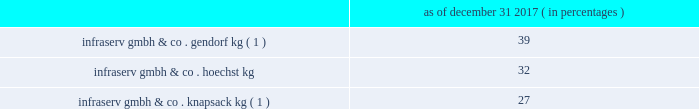Table of contents other equity method investments infraservs .
We hold indirect ownership interests in several german infraserv groups that own and develop industrial parks and provide on-site general and administrative support to tenants .
Our ownership interest in the equity investments in infraserv affiliates are as follows : as of december 31 , 2017 ( in percentages ) infraserv gmbh & co .
Gendorf kg ( 1 ) ................................................................................................... .
39 .
Infraserv gmbh & co .
Knapsack kg ( 1 ) ................................................................................................ .
27 ______________________________ ( 1 ) see note 29 - subsequent events in the accompanying consolidated financial statements for further information .
Research and development our business models leverage innovation and conduct research and development activities to develop new , and optimize existing , production technologies , as well as to develop commercially viable new products and applications .
Research and development expense was $ 72 million , $ 78 million and $ 119 million for the years ended december 31 , 2017 , 2016 and 2015 , respectively .
We consider the amounts spent during each of the last three fiscal years on research and development activities to be sufficient to execute our current strategic initiatives .
Intellectual property we attach importance to protecting our intellectual property , including safeguarding our confidential information and through our patents , trademarks and copyrights , in order to preserve our investment in research and development , manufacturing and marketing .
Patents may cover processes , equipment , products , intermediate products and product uses .
We also seek to register trademarks as a means of protecting the brand names of our company and products .
Patents .
In most industrial countries , patent protection exists for new substances and formulations , as well as for certain unique applications and production processes .
However , we do business in regions of the world where intellectual property protection may be limited and difficult to enforce .
Confidential information .
We maintain stringent information security policies and procedures wherever we do business .
Such information security policies and procedures include data encryption , controls over the disclosure and safekeeping of confidential information and trade secrets , as well as employee awareness training .
Trademarks .
Amcel ae , aoplus ae , ateva ae , avicor ae , celanese ae , celanex ae , celcon ae , celfx ae , celstran ae , celvolit ae , clarifoil ae , dur- o-set ae , ecomid ae , ecovae ae , forflex ae , forprene ae , frianyl ae , fortron ae , ghr ae , gumfit ae , gur ae , hostaform ae , laprene ae , metalx ae , mowilith ae , mt ae , nilamid ae , nivionplast ae , nutrinova ae , nylfor ae , pibiflex ae , pibifor ae , pibiter ae , polifor ae , resyn ae , riteflex ae , slidex ae , sofprene ae , sofpur ae , sunett ae , talcoprene ae , tecnoprene ae , thermx ae , tufcor ae , vantage ae , vectra ae , vinac ae , vinamul ae , vitaldose ae , zenite ae and certain other branded products and services named in this document are registered or reserved trademarks or service marks owned or licensed by celanese .
The foregoing is not intended to be an exhaustive or comprehensive list of all registered or reserved trademarks and service marks owned or licensed by celanese .
Fortron ae is a registered trademark of fortron industries llc .
Hostaform ae is a registered trademark of hoechst gmbh .
Mowilith ae and nilamid ae are registered trademarks of celanese in most european countries .
We monitor competitive developments and defend against infringements on our intellectual property rights .
Neither celanese nor any particular business segment is materially dependent upon any one patent , trademark , copyright or trade secret .
Environmental and other regulation matters pertaining to environmental and other regulations are discussed in item 1a .
Risk factors , as well as note 2 - summary of accounting policies , note 16 - environmental and note 24 - commitments and contingencies in the accompanying consolidated financial statements. .
What was the percentage change in the research and development costs from 2015 to 2016? 
Rationale: the percent is the difference in the amounts divided by the original amount
Computations: ((78 - 119) / 119)
Answer: -0.34454. 